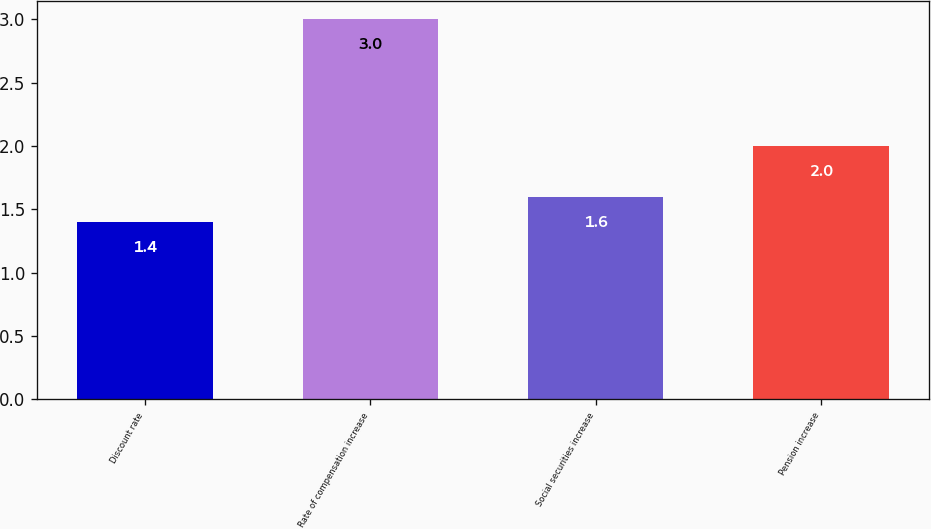Convert chart to OTSL. <chart><loc_0><loc_0><loc_500><loc_500><bar_chart><fcel>Discount rate<fcel>Rate of compensation increase<fcel>Social securities increase<fcel>Pension increase<nl><fcel>1.4<fcel>3<fcel>1.6<fcel>2<nl></chart> 